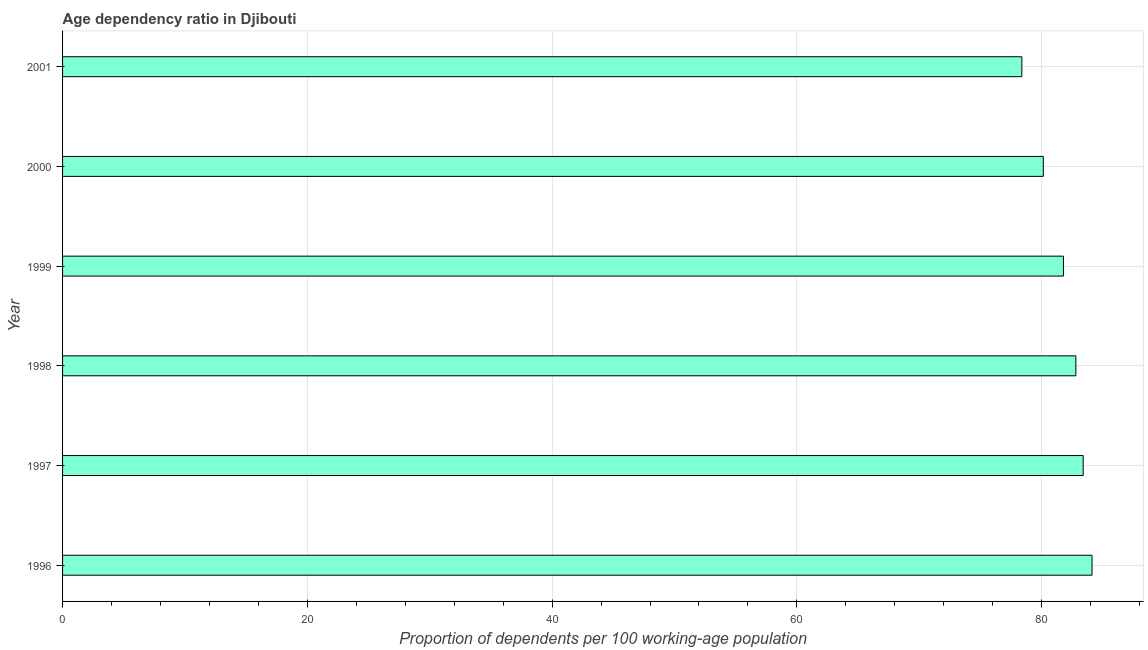Does the graph contain any zero values?
Your answer should be very brief. No. What is the title of the graph?
Ensure brevity in your answer.  Age dependency ratio in Djibouti. What is the label or title of the X-axis?
Keep it short and to the point. Proportion of dependents per 100 working-age population. What is the label or title of the Y-axis?
Your response must be concise. Year. What is the age dependency ratio in 2000?
Your answer should be compact. 80.14. Across all years, what is the maximum age dependency ratio?
Ensure brevity in your answer.  84.12. Across all years, what is the minimum age dependency ratio?
Provide a succinct answer. 78.38. What is the sum of the age dependency ratio?
Offer a terse response. 490.61. What is the difference between the age dependency ratio in 2000 and 2001?
Provide a succinct answer. 1.75. What is the average age dependency ratio per year?
Offer a terse response. 81.77. What is the median age dependency ratio?
Keep it short and to the point. 82.29. Do a majority of the years between 1997 and 1996 (inclusive) have age dependency ratio greater than 4 ?
Ensure brevity in your answer.  No. What is the ratio of the age dependency ratio in 1997 to that in 2000?
Your answer should be compact. 1.04. Is the difference between the age dependency ratio in 1997 and 2001 greater than the difference between any two years?
Offer a terse response. No. What is the difference between the highest and the second highest age dependency ratio?
Ensure brevity in your answer.  0.72. Is the sum of the age dependency ratio in 1996 and 2000 greater than the maximum age dependency ratio across all years?
Your answer should be very brief. Yes. What is the difference between the highest and the lowest age dependency ratio?
Give a very brief answer. 5.73. How many bars are there?
Your answer should be compact. 6. Are all the bars in the graph horizontal?
Provide a succinct answer. Yes. How many years are there in the graph?
Ensure brevity in your answer.  6. Are the values on the major ticks of X-axis written in scientific E-notation?
Your answer should be very brief. No. What is the Proportion of dependents per 100 working-age population of 1996?
Provide a succinct answer. 84.12. What is the Proportion of dependents per 100 working-age population in 1997?
Offer a very short reply. 83.4. What is the Proportion of dependents per 100 working-age population of 1998?
Your answer should be very brief. 82.8. What is the Proportion of dependents per 100 working-age population of 1999?
Offer a very short reply. 81.78. What is the Proportion of dependents per 100 working-age population of 2000?
Give a very brief answer. 80.14. What is the Proportion of dependents per 100 working-age population of 2001?
Ensure brevity in your answer.  78.38. What is the difference between the Proportion of dependents per 100 working-age population in 1996 and 1997?
Provide a short and direct response. 0.72. What is the difference between the Proportion of dependents per 100 working-age population in 1996 and 1998?
Your response must be concise. 1.32. What is the difference between the Proportion of dependents per 100 working-age population in 1996 and 1999?
Keep it short and to the point. 2.34. What is the difference between the Proportion of dependents per 100 working-age population in 1996 and 2000?
Keep it short and to the point. 3.98. What is the difference between the Proportion of dependents per 100 working-age population in 1996 and 2001?
Your answer should be compact. 5.73. What is the difference between the Proportion of dependents per 100 working-age population in 1997 and 1998?
Give a very brief answer. 0.6. What is the difference between the Proportion of dependents per 100 working-age population in 1997 and 1999?
Your response must be concise. 1.61. What is the difference between the Proportion of dependents per 100 working-age population in 1997 and 2000?
Your response must be concise. 3.26. What is the difference between the Proportion of dependents per 100 working-age population in 1997 and 2001?
Make the answer very short. 5.01. What is the difference between the Proportion of dependents per 100 working-age population in 1998 and 1999?
Provide a succinct answer. 1.02. What is the difference between the Proportion of dependents per 100 working-age population in 1998 and 2000?
Keep it short and to the point. 2.66. What is the difference between the Proportion of dependents per 100 working-age population in 1998 and 2001?
Offer a very short reply. 4.41. What is the difference between the Proportion of dependents per 100 working-age population in 1999 and 2000?
Offer a terse response. 1.65. What is the difference between the Proportion of dependents per 100 working-age population in 1999 and 2001?
Keep it short and to the point. 3.4. What is the difference between the Proportion of dependents per 100 working-age population in 2000 and 2001?
Offer a very short reply. 1.75. What is the ratio of the Proportion of dependents per 100 working-age population in 1996 to that in 2000?
Offer a terse response. 1.05. What is the ratio of the Proportion of dependents per 100 working-age population in 1996 to that in 2001?
Offer a terse response. 1.07. What is the ratio of the Proportion of dependents per 100 working-age population in 1997 to that in 1998?
Your answer should be compact. 1.01. What is the ratio of the Proportion of dependents per 100 working-age population in 1997 to that in 1999?
Give a very brief answer. 1.02. What is the ratio of the Proportion of dependents per 100 working-age population in 1997 to that in 2000?
Give a very brief answer. 1.04. What is the ratio of the Proportion of dependents per 100 working-age population in 1997 to that in 2001?
Keep it short and to the point. 1.06. What is the ratio of the Proportion of dependents per 100 working-age population in 1998 to that in 1999?
Make the answer very short. 1.01. What is the ratio of the Proportion of dependents per 100 working-age population in 1998 to that in 2000?
Keep it short and to the point. 1.03. What is the ratio of the Proportion of dependents per 100 working-age population in 1998 to that in 2001?
Ensure brevity in your answer.  1.06. What is the ratio of the Proportion of dependents per 100 working-age population in 1999 to that in 2000?
Your answer should be very brief. 1.02. What is the ratio of the Proportion of dependents per 100 working-age population in 1999 to that in 2001?
Your answer should be very brief. 1.04. What is the ratio of the Proportion of dependents per 100 working-age population in 2000 to that in 2001?
Keep it short and to the point. 1.02. 